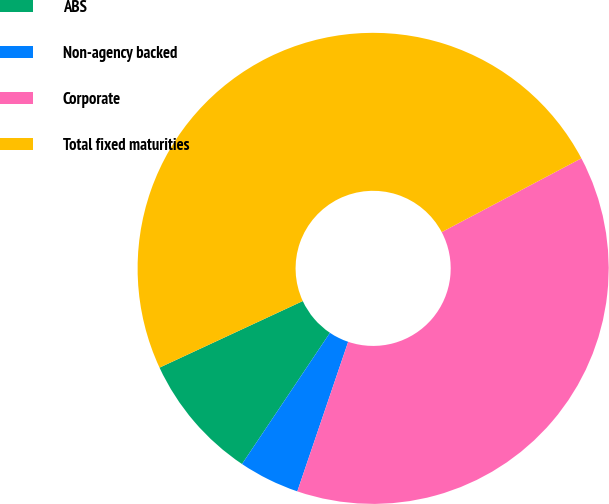Convert chart to OTSL. <chart><loc_0><loc_0><loc_500><loc_500><pie_chart><fcel>ABS<fcel>Non-agency backed<fcel>Corporate<fcel>Total fixed maturities<nl><fcel>8.68%<fcel>4.18%<fcel>37.95%<fcel>49.18%<nl></chart> 